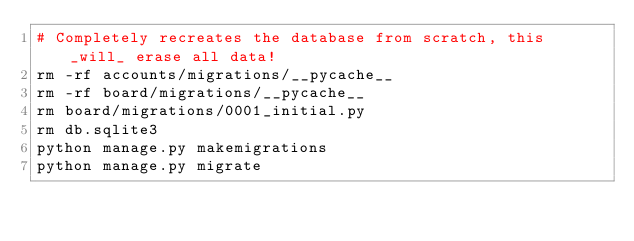Convert code to text. <code><loc_0><loc_0><loc_500><loc_500><_Bash_># Completely recreates the database from scratch, this _will_ erase all data!
rm -rf accounts/migrations/__pycache__
rm -rf board/migrations/__pycache__
rm board/migrations/0001_initial.py
rm db.sqlite3
python manage.py makemigrations
python manage.py migrate
</code> 